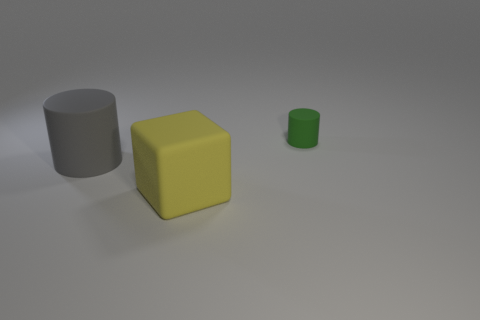Add 3 big gray rubber things. How many objects exist? 6 Subtract 1 yellow cubes. How many objects are left? 2 Subtract all cubes. How many objects are left? 2 Subtract all big red shiny blocks. Subtract all gray cylinders. How many objects are left? 2 Add 3 large gray matte things. How many large gray matte things are left? 4 Add 2 tiny cyan shiny things. How many tiny cyan shiny things exist? 2 